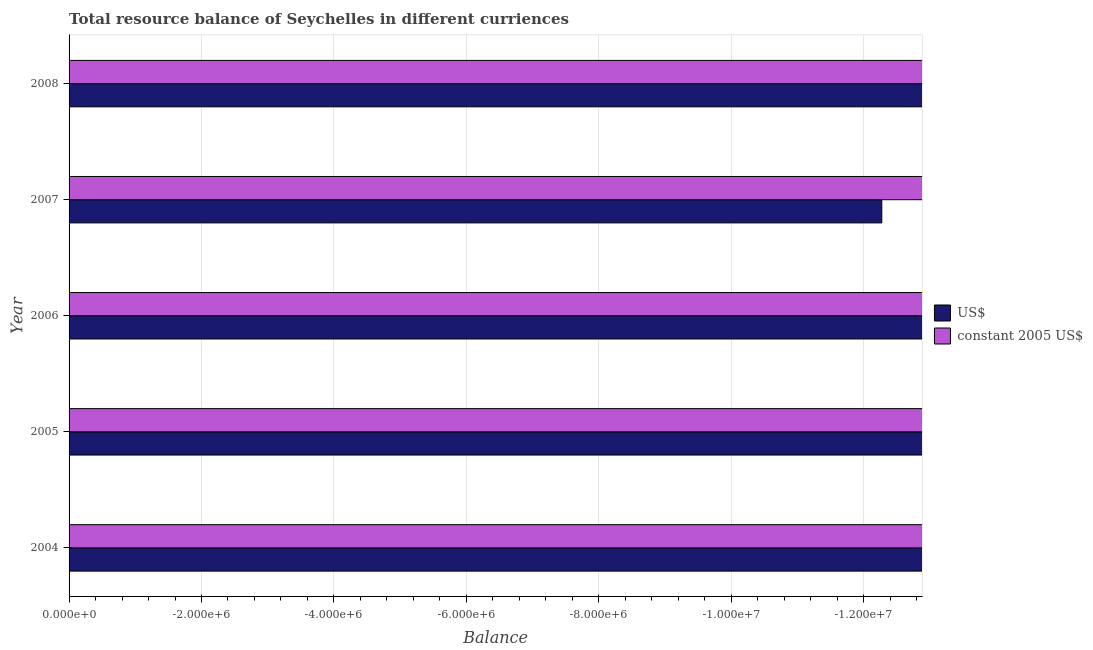How many different coloured bars are there?
Offer a terse response. 0. How many bars are there on the 4th tick from the bottom?
Offer a terse response. 0. In how many cases, is the number of bars for a given year not equal to the number of legend labels?
Provide a succinct answer. 5. Across all years, what is the minimum resource balance in constant us$?
Provide a short and direct response. 0. What is the total resource balance in us$ in the graph?
Ensure brevity in your answer.  0. What is the average resource balance in us$ per year?
Your response must be concise. 0. In how many years, is the resource balance in us$ greater than the average resource balance in us$ taken over all years?
Your response must be concise. 0. How many bars are there?
Give a very brief answer. 0. How many years are there in the graph?
Your answer should be compact. 5. What is the difference between two consecutive major ticks on the X-axis?
Your answer should be very brief. 2.00e+06. Are the values on the major ticks of X-axis written in scientific E-notation?
Provide a short and direct response. Yes. Does the graph contain any zero values?
Your answer should be very brief. Yes. Where does the legend appear in the graph?
Offer a terse response. Center right. How many legend labels are there?
Ensure brevity in your answer.  2. What is the title of the graph?
Keep it short and to the point. Total resource balance of Seychelles in different curriences. Does "Grants" appear as one of the legend labels in the graph?
Offer a terse response. No. What is the label or title of the X-axis?
Provide a succinct answer. Balance. What is the Balance of US$ in 2004?
Offer a very short reply. 0. What is the Balance in constant 2005 US$ in 2004?
Make the answer very short. 0. What is the Balance of constant 2005 US$ in 2005?
Your response must be concise. 0. What is the Balance of constant 2005 US$ in 2008?
Ensure brevity in your answer.  0. What is the total Balance in constant 2005 US$ in the graph?
Your answer should be very brief. 0. 